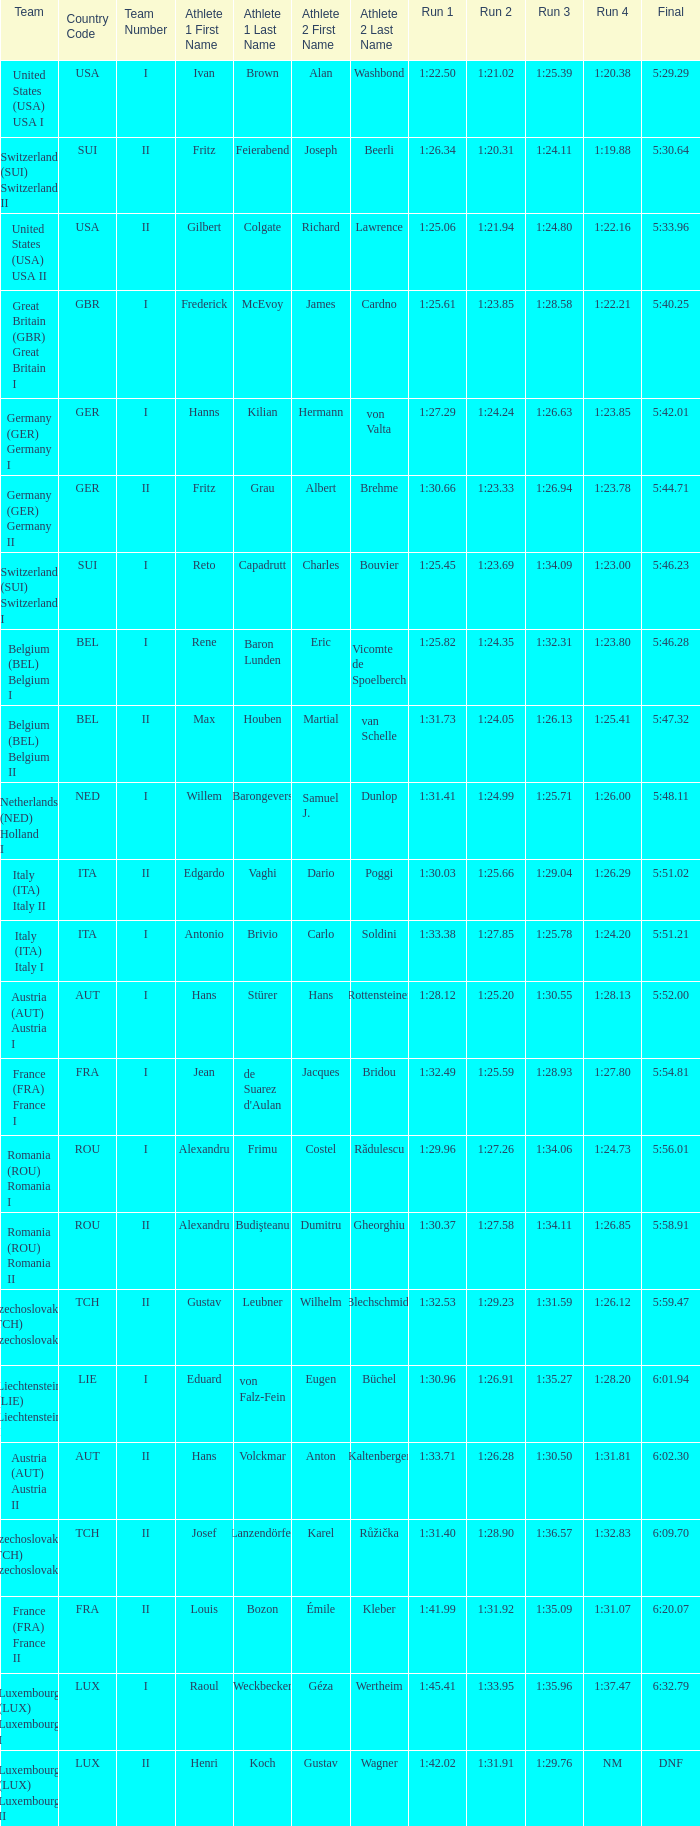03? 1:25.66. 